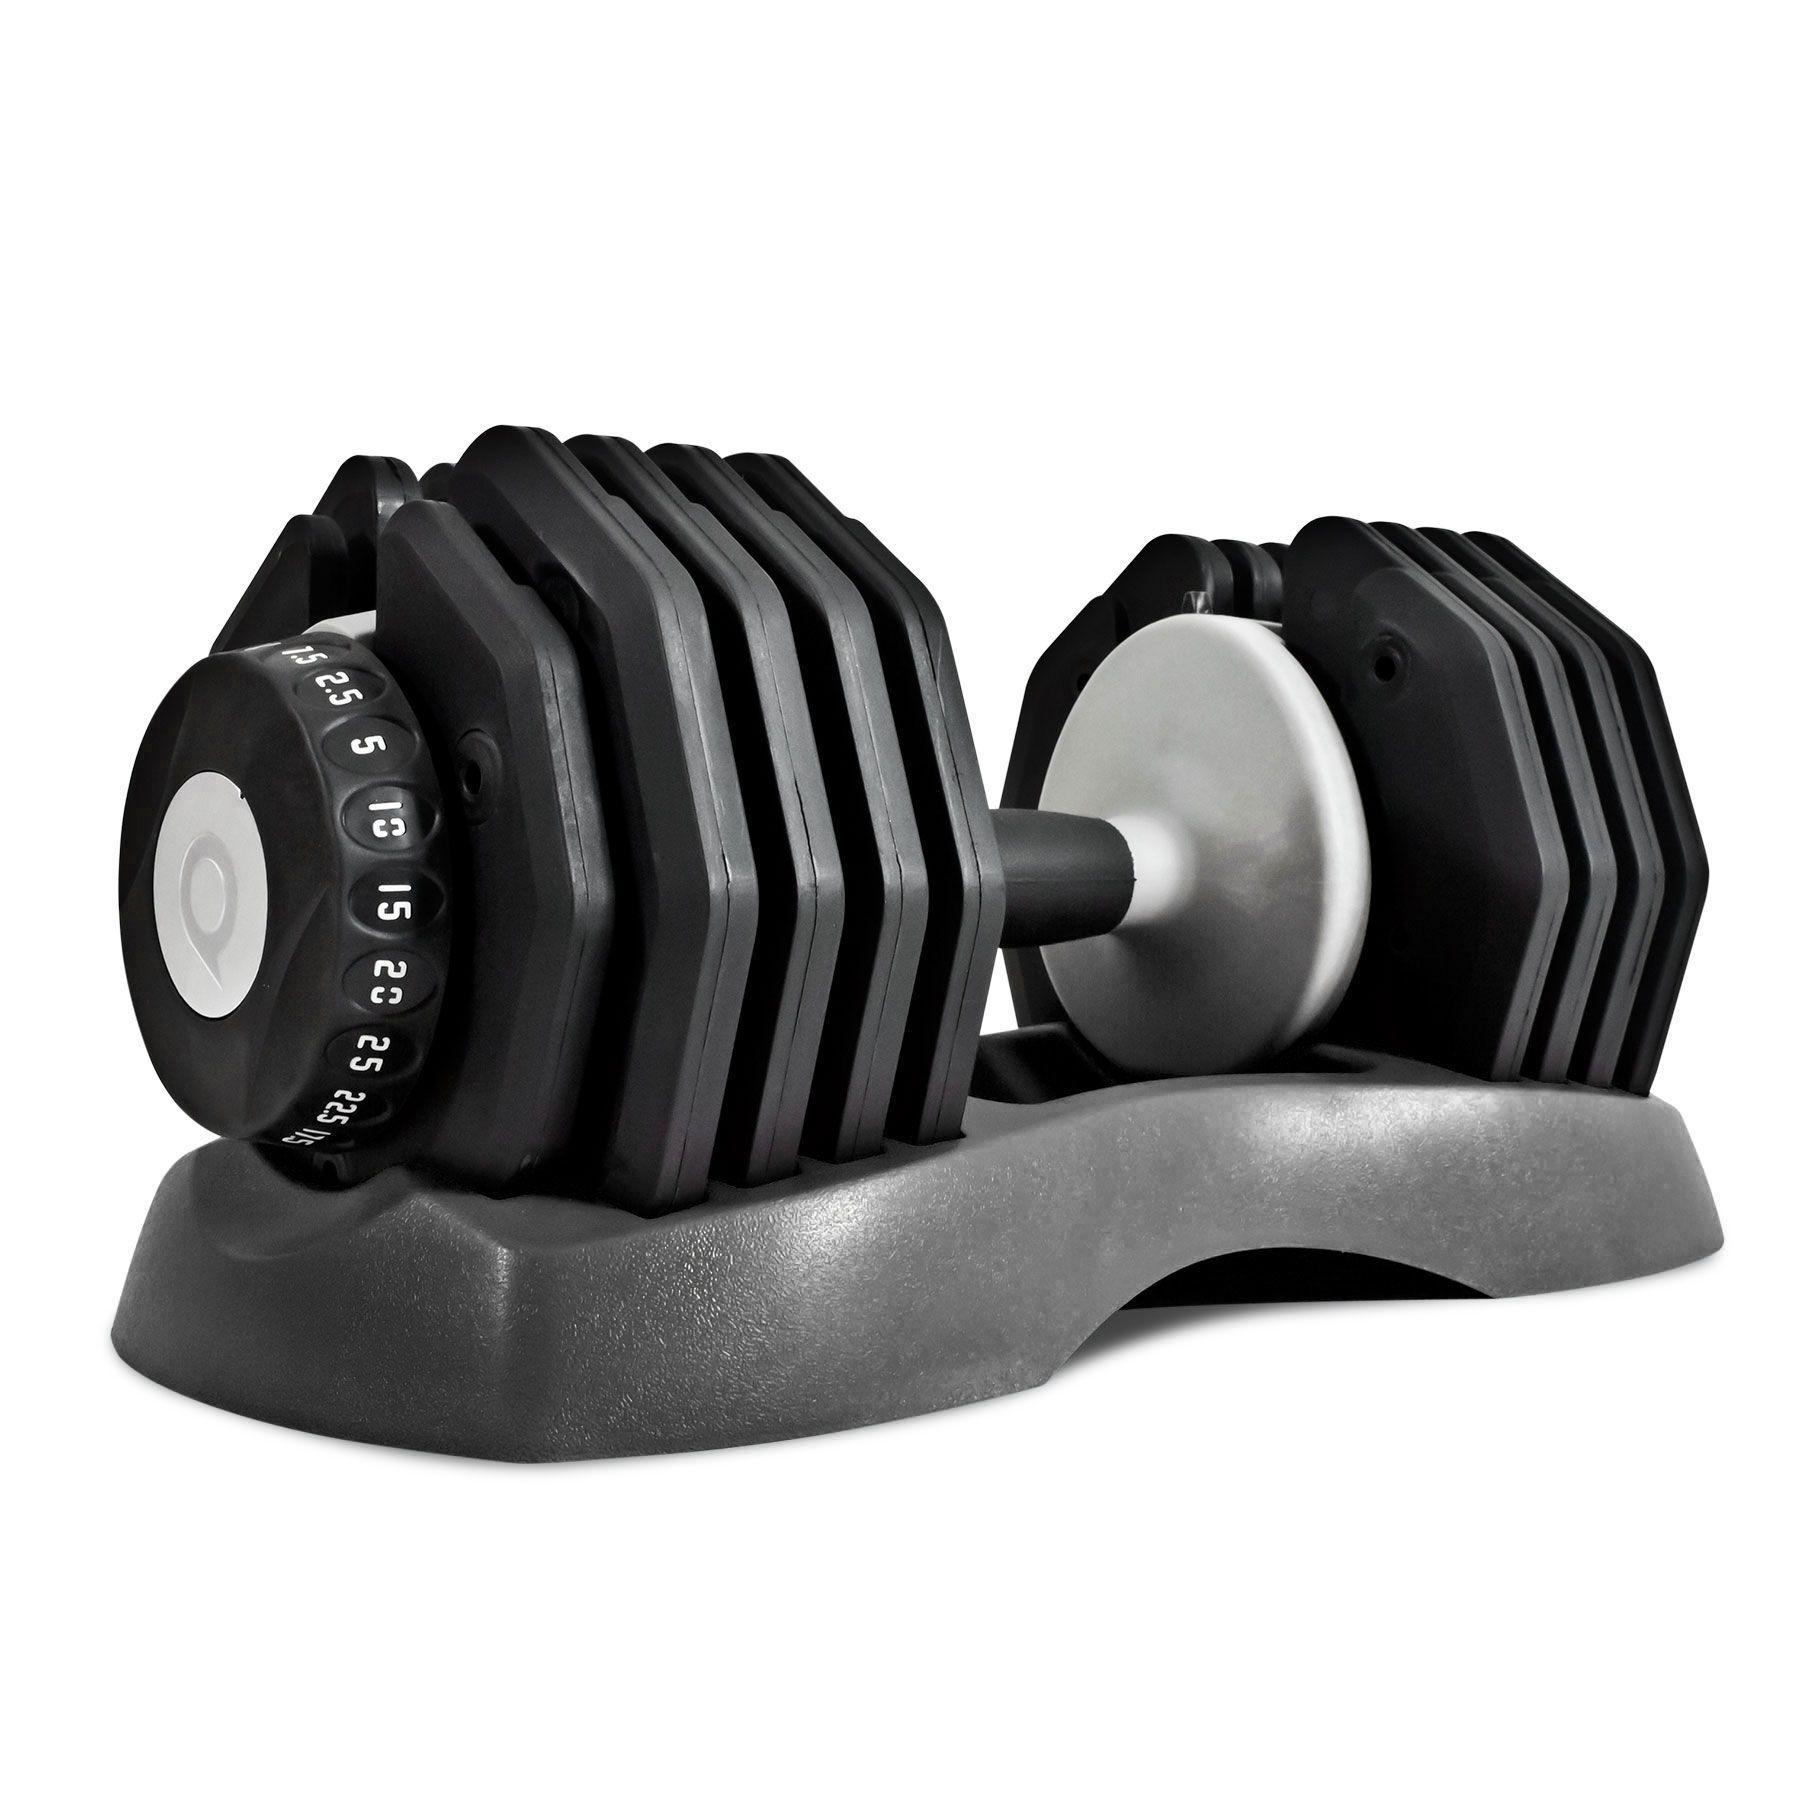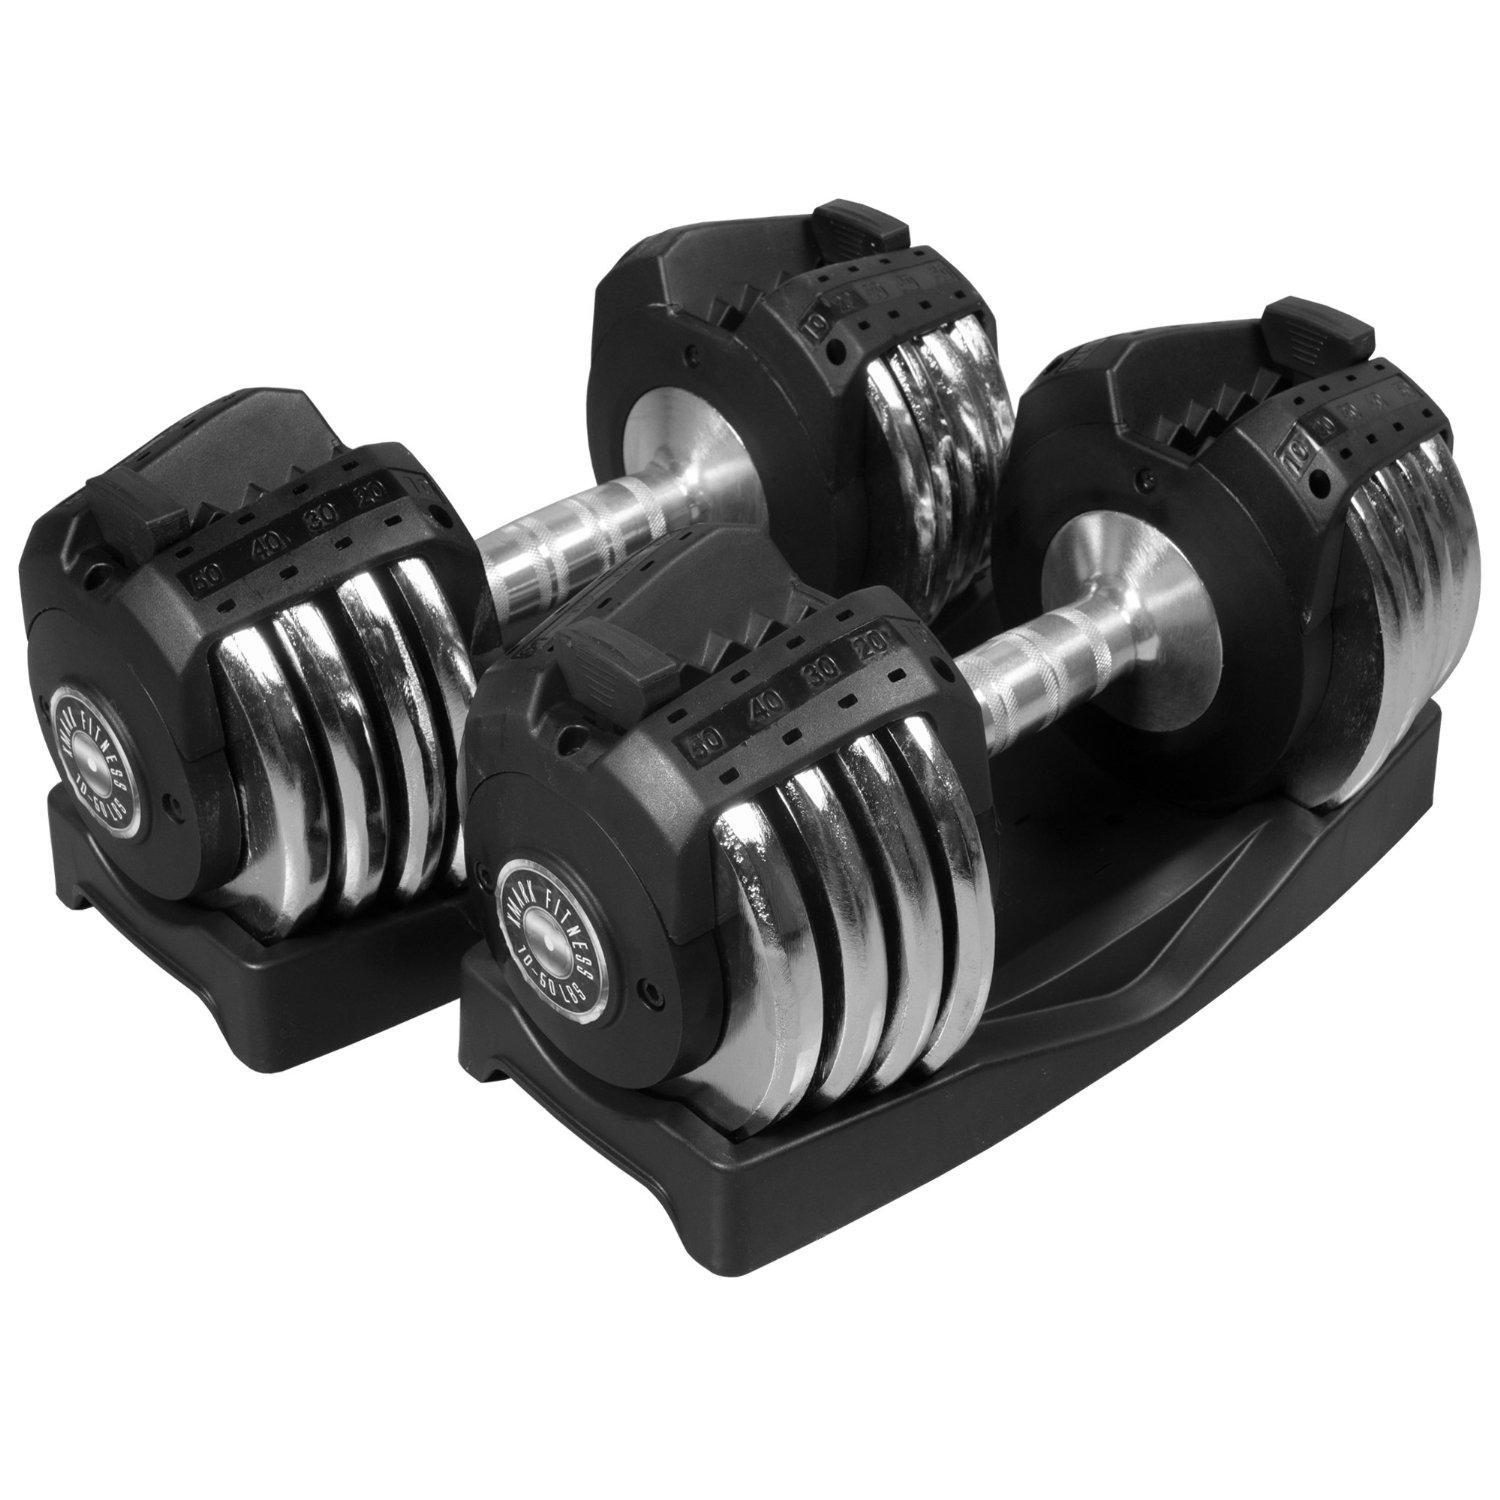The first image is the image on the left, the second image is the image on the right. Examine the images to the left and right. Is the description "The left and right image contains a total of four dumbbells and four racks." accurate? Answer yes or no. No. The first image is the image on the left, the second image is the image on the right. Considering the images on both sides, is "There are four barbell stands." valid? Answer yes or no. No. 